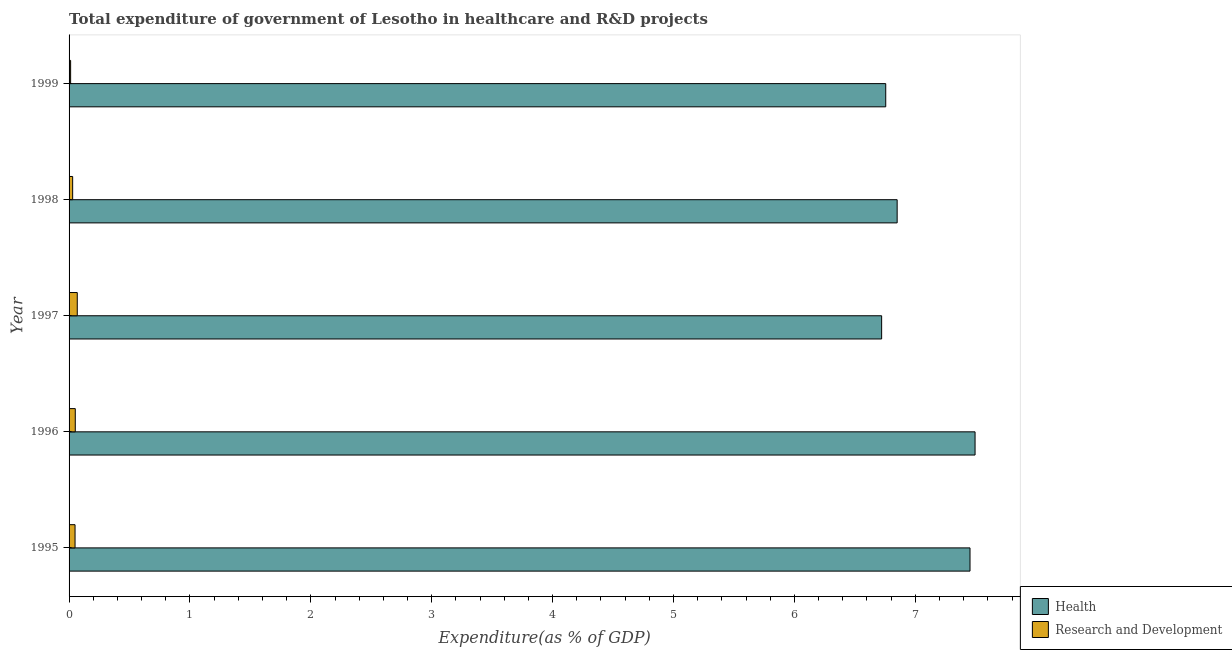Are the number of bars per tick equal to the number of legend labels?
Your answer should be very brief. Yes. How many bars are there on the 5th tick from the top?
Provide a succinct answer. 2. How many bars are there on the 2nd tick from the bottom?
Make the answer very short. 2. What is the label of the 2nd group of bars from the top?
Your answer should be very brief. 1998. In how many cases, is the number of bars for a given year not equal to the number of legend labels?
Your response must be concise. 0. What is the expenditure in healthcare in 1998?
Offer a terse response. 6.85. Across all years, what is the maximum expenditure in r&d?
Your answer should be very brief. 0.07. Across all years, what is the minimum expenditure in r&d?
Offer a very short reply. 0.01. In which year was the expenditure in r&d maximum?
Your response must be concise. 1997. In which year was the expenditure in healthcare minimum?
Keep it short and to the point. 1997. What is the total expenditure in healthcare in the graph?
Give a very brief answer. 35.27. What is the difference between the expenditure in healthcare in 1995 and that in 1996?
Provide a succinct answer. -0.04. What is the difference between the expenditure in healthcare in 1998 and the expenditure in r&d in 1995?
Keep it short and to the point. 6.8. What is the average expenditure in r&d per year?
Provide a succinct answer. 0.04. In the year 1998, what is the difference between the expenditure in healthcare and expenditure in r&d?
Offer a terse response. 6.82. In how many years, is the expenditure in r&d greater than 6.2 %?
Provide a short and direct response. 0. What is the difference between the highest and the second highest expenditure in healthcare?
Offer a very short reply. 0.04. What does the 2nd bar from the top in 1997 represents?
Ensure brevity in your answer.  Health. What does the 2nd bar from the bottom in 1997 represents?
Provide a short and direct response. Research and Development. How many bars are there?
Provide a short and direct response. 10. Are all the bars in the graph horizontal?
Offer a terse response. Yes. How many legend labels are there?
Make the answer very short. 2. What is the title of the graph?
Provide a short and direct response. Total expenditure of government of Lesotho in healthcare and R&D projects. What is the label or title of the X-axis?
Provide a succinct answer. Expenditure(as % of GDP). What is the label or title of the Y-axis?
Your answer should be compact. Year. What is the Expenditure(as % of GDP) of Health in 1995?
Offer a terse response. 7.45. What is the Expenditure(as % of GDP) of Research and Development in 1995?
Provide a short and direct response. 0.05. What is the Expenditure(as % of GDP) of Health in 1996?
Provide a succinct answer. 7.49. What is the Expenditure(as % of GDP) in Research and Development in 1996?
Your response must be concise. 0.05. What is the Expenditure(as % of GDP) in Health in 1997?
Your response must be concise. 6.72. What is the Expenditure(as % of GDP) in Research and Development in 1997?
Give a very brief answer. 0.07. What is the Expenditure(as % of GDP) of Health in 1998?
Your answer should be very brief. 6.85. What is the Expenditure(as % of GDP) of Research and Development in 1998?
Your answer should be very brief. 0.03. What is the Expenditure(as % of GDP) in Health in 1999?
Your answer should be compact. 6.76. What is the Expenditure(as % of GDP) in Research and Development in 1999?
Your response must be concise. 0.01. Across all years, what is the maximum Expenditure(as % of GDP) of Health?
Provide a short and direct response. 7.49. Across all years, what is the maximum Expenditure(as % of GDP) in Research and Development?
Your response must be concise. 0.07. Across all years, what is the minimum Expenditure(as % of GDP) in Health?
Offer a very short reply. 6.72. Across all years, what is the minimum Expenditure(as % of GDP) in Research and Development?
Offer a terse response. 0.01. What is the total Expenditure(as % of GDP) in Health in the graph?
Provide a short and direct response. 35.27. What is the total Expenditure(as % of GDP) in Research and Development in the graph?
Provide a succinct answer. 0.21. What is the difference between the Expenditure(as % of GDP) of Health in 1995 and that in 1996?
Your answer should be compact. -0.04. What is the difference between the Expenditure(as % of GDP) in Research and Development in 1995 and that in 1996?
Provide a succinct answer. -0. What is the difference between the Expenditure(as % of GDP) of Health in 1995 and that in 1997?
Your answer should be very brief. 0.73. What is the difference between the Expenditure(as % of GDP) in Research and Development in 1995 and that in 1997?
Your answer should be very brief. -0.02. What is the difference between the Expenditure(as % of GDP) in Health in 1995 and that in 1998?
Ensure brevity in your answer.  0.6. What is the difference between the Expenditure(as % of GDP) of Research and Development in 1995 and that in 1998?
Ensure brevity in your answer.  0.02. What is the difference between the Expenditure(as % of GDP) of Health in 1995 and that in 1999?
Your response must be concise. 0.7. What is the difference between the Expenditure(as % of GDP) in Research and Development in 1995 and that in 1999?
Make the answer very short. 0.04. What is the difference between the Expenditure(as % of GDP) of Health in 1996 and that in 1997?
Give a very brief answer. 0.77. What is the difference between the Expenditure(as % of GDP) of Research and Development in 1996 and that in 1997?
Offer a terse response. -0.02. What is the difference between the Expenditure(as % of GDP) of Health in 1996 and that in 1998?
Your response must be concise. 0.64. What is the difference between the Expenditure(as % of GDP) in Research and Development in 1996 and that in 1998?
Make the answer very short. 0.02. What is the difference between the Expenditure(as % of GDP) in Health in 1996 and that in 1999?
Provide a short and direct response. 0.74. What is the difference between the Expenditure(as % of GDP) in Research and Development in 1996 and that in 1999?
Your answer should be compact. 0.04. What is the difference between the Expenditure(as % of GDP) of Health in 1997 and that in 1998?
Your response must be concise. -0.13. What is the difference between the Expenditure(as % of GDP) of Research and Development in 1997 and that in 1998?
Offer a terse response. 0.04. What is the difference between the Expenditure(as % of GDP) in Health in 1997 and that in 1999?
Ensure brevity in your answer.  -0.03. What is the difference between the Expenditure(as % of GDP) in Research and Development in 1997 and that in 1999?
Keep it short and to the point. 0.05. What is the difference between the Expenditure(as % of GDP) of Health in 1998 and that in 1999?
Your answer should be very brief. 0.09. What is the difference between the Expenditure(as % of GDP) in Research and Development in 1998 and that in 1999?
Provide a succinct answer. 0.02. What is the difference between the Expenditure(as % of GDP) in Health in 1995 and the Expenditure(as % of GDP) in Research and Development in 1996?
Ensure brevity in your answer.  7.4. What is the difference between the Expenditure(as % of GDP) in Health in 1995 and the Expenditure(as % of GDP) in Research and Development in 1997?
Keep it short and to the point. 7.38. What is the difference between the Expenditure(as % of GDP) in Health in 1995 and the Expenditure(as % of GDP) in Research and Development in 1998?
Make the answer very short. 7.42. What is the difference between the Expenditure(as % of GDP) in Health in 1995 and the Expenditure(as % of GDP) in Research and Development in 1999?
Your response must be concise. 7.44. What is the difference between the Expenditure(as % of GDP) of Health in 1996 and the Expenditure(as % of GDP) of Research and Development in 1997?
Give a very brief answer. 7.43. What is the difference between the Expenditure(as % of GDP) in Health in 1996 and the Expenditure(as % of GDP) in Research and Development in 1998?
Keep it short and to the point. 7.46. What is the difference between the Expenditure(as % of GDP) of Health in 1996 and the Expenditure(as % of GDP) of Research and Development in 1999?
Give a very brief answer. 7.48. What is the difference between the Expenditure(as % of GDP) of Health in 1997 and the Expenditure(as % of GDP) of Research and Development in 1998?
Keep it short and to the point. 6.69. What is the difference between the Expenditure(as % of GDP) of Health in 1997 and the Expenditure(as % of GDP) of Research and Development in 1999?
Give a very brief answer. 6.71. What is the difference between the Expenditure(as % of GDP) in Health in 1998 and the Expenditure(as % of GDP) in Research and Development in 1999?
Provide a short and direct response. 6.84. What is the average Expenditure(as % of GDP) of Health per year?
Your response must be concise. 7.05. What is the average Expenditure(as % of GDP) of Research and Development per year?
Offer a terse response. 0.04. In the year 1995, what is the difference between the Expenditure(as % of GDP) in Health and Expenditure(as % of GDP) in Research and Development?
Provide a short and direct response. 7.4. In the year 1996, what is the difference between the Expenditure(as % of GDP) in Health and Expenditure(as % of GDP) in Research and Development?
Provide a short and direct response. 7.44. In the year 1997, what is the difference between the Expenditure(as % of GDP) of Health and Expenditure(as % of GDP) of Research and Development?
Your answer should be compact. 6.65. In the year 1998, what is the difference between the Expenditure(as % of GDP) in Health and Expenditure(as % of GDP) in Research and Development?
Make the answer very short. 6.82. In the year 1999, what is the difference between the Expenditure(as % of GDP) of Health and Expenditure(as % of GDP) of Research and Development?
Provide a succinct answer. 6.74. What is the ratio of the Expenditure(as % of GDP) in Research and Development in 1995 to that in 1996?
Make the answer very short. 0.96. What is the ratio of the Expenditure(as % of GDP) in Health in 1995 to that in 1997?
Your answer should be very brief. 1.11. What is the ratio of the Expenditure(as % of GDP) in Research and Development in 1995 to that in 1997?
Keep it short and to the point. 0.73. What is the ratio of the Expenditure(as % of GDP) in Health in 1995 to that in 1998?
Give a very brief answer. 1.09. What is the ratio of the Expenditure(as % of GDP) in Research and Development in 1995 to that in 1998?
Give a very brief answer. 1.67. What is the ratio of the Expenditure(as % of GDP) in Health in 1995 to that in 1999?
Give a very brief answer. 1.1. What is the ratio of the Expenditure(as % of GDP) of Research and Development in 1995 to that in 1999?
Your response must be concise. 3.85. What is the ratio of the Expenditure(as % of GDP) in Health in 1996 to that in 1997?
Ensure brevity in your answer.  1.11. What is the ratio of the Expenditure(as % of GDP) in Research and Development in 1996 to that in 1997?
Your answer should be very brief. 0.76. What is the ratio of the Expenditure(as % of GDP) of Health in 1996 to that in 1998?
Your answer should be very brief. 1.09. What is the ratio of the Expenditure(as % of GDP) of Research and Development in 1996 to that in 1998?
Your response must be concise. 1.73. What is the ratio of the Expenditure(as % of GDP) of Health in 1996 to that in 1999?
Offer a terse response. 1.11. What is the ratio of the Expenditure(as % of GDP) of Research and Development in 1996 to that in 1999?
Give a very brief answer. 4. What is the ratio of the Expenditure(as % of GDP) of Health in 1997 to that in 1998?
Provide a short and direct response. 0.98. What is the ratio of the Expenditure(as % of GDP) in Research and Development in 1997 to that in 1998?
Your answer should be compact. 2.29. What is the ratio of the Expenditure(as % of GDP) in Health in 1997 to that in 1999?
Your answer should be compact. 0.99. What is the ratio of the Expenditure(as % of GDP) of Research and Development in 1997 to that in 1999?
Provide a succinct answer. 5.28. What is the ratio of the Expenditure(as % of GDP) in Research and Development in 1998 to that in 1999?
Ensure brevity in your answer.  2.31. What is the difference between the highest and the second highest Expenditure(as % of GDP) in Health?
Give a very brief answer. 0.04. What is the difference between the highest and the second highest Expenditure(as % of GDP) in Research and Development?
Give a very brief answer. 0.02. What is the difference between the highest and the lowest Expenditure(as % of GDP) in Health?
Your response must be concise. 0.77. What is the difference between the highest and the lowest Expenditure(as % of GDP) of Research and Development?
Offer a very short reply. 0.05. 